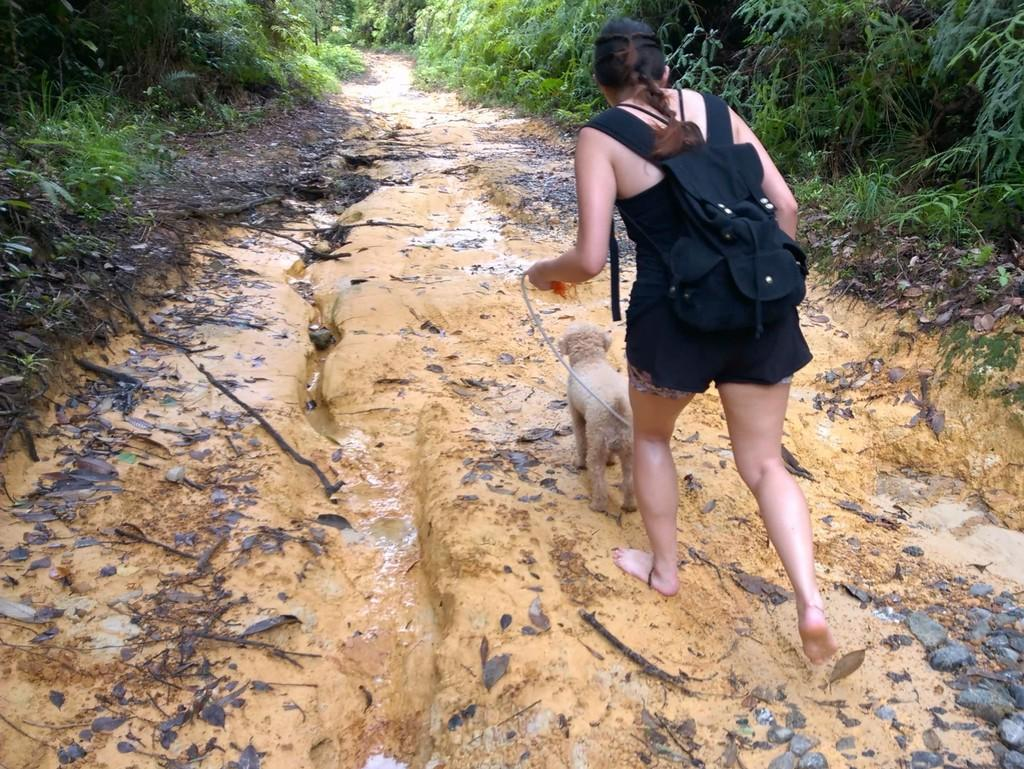What is the color of the ground in the image? The ground in the image is brown. What is the woman in the image doing? The woman is holding a dog in the image. Where are plants located in the image? There are plants on both the right and left sides of the image. Can you tell me how high the woman is jumping with the dog in the image? There is no indication in the image that the woman is jumping with the dog; she is simply holding the dog. 